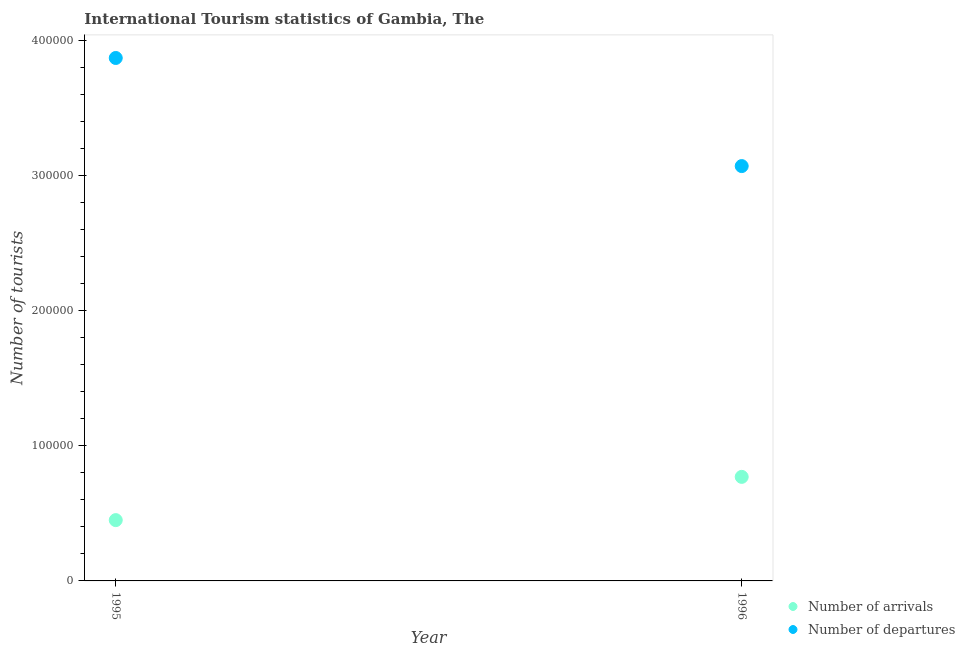How many different coloured dotlines are there?
Your answer should be compact. 2. Is the number of dotlines equal to the number of legend labels?
Offer a very short reply. Yes. What is the number of tourist departures in 1995?
Make the answer very short. 3.87e+05. Across all years, what is the maximum number of tourist departures?
Provide a succinct answer. 3.87e+05. Across all years, what is the minimum number of tourist arrivals?
Provide a short and direct response. 4.50e+04. In which year was the number of tourist departures maximum?
Ensure brevity in your answer.  1995. What is the total number of tourist arrivals in the graph?
Ensure brevity in your answer.  1.22e+05. What is the difference between the number of tourist arrivals in 1995 and that in 1996?
Offer a very short reply. -3.20e+04. What is the difference between the number of tourist departures in 1996 and the number of tourist arrivals in 1995?
Provide a short and direct response. 2.62e+05. What is the average number of tourist arrivals per year?
Provide a succinct answer. 6.10e+04. In the year 1996, what is the difference between the number of tourist arrivals and number of tourist departures?
Give a very brief answer. -2.30e+05. What is the ratio of the number of tourist departures in 1995 to that in 1996?
Make the answer very short. 1.26. Does the number of tourist departures monotonically increase over the years?
Your response must be concise. No. How many dotlines are there?
Keep it short and to the point. 2. How many years are there in the graph?
Offer a terse response. 2. Does the graph contain any zero values?
Your response must be concise. No. Does the graph contain grids?
Your response must be concise. No. Where does the legend appear in the graph?
Make the answer very short. Bottom right. How many legend labels are there?
Your answer should be compact. 2. What is the title of the graph?
Make the answer very short. International Tourism statistics of Gambia, The. Does "Travel services" appear as one of the legend labels in the graph?
Your answer should be compact. No. What is the label or title of the X-axis?
Offer a terse response. Year. What is the label or title of the Y-axis?
Your answer should be very brief. Number of tourists. What is the Number of tourists in Number of arrivals in 1995?
Offer a very short reply. 4.50e+04. What is the Number of tourists of Number of departures in 1995?
Offer a terse response. 3.87e+05. What is the Number of tourists in Number of arrivals in 1996?
Offer a very short reply. 7.70e+04. What is the Number of tourists of Number of departures in 1996?
Your answer should be compact. 3.07e+05. Across all years, what is the maximum Number of tourists of Number of arrivals?
Offer a terse response. 7.70e+04. Across all years, what is the maximum Number of tourists of Number of departures?
Give a very brief answer. 3.87e+05. Across all years, what is the minimum Number of tourists of Number of arrivals?
Ensure brevity in your answer.  4.50e+04. Across all years, what is the minimum Number of tourists of Number of departures?
Give a very brief answer. 3.07e+05. What is the total Number of tourists in Number of arrivals in the graph?
Your response must be concise. 1.22e+05. What is the total Number of tourists in Number of departures in the graph?
Offer a very short reply. 6.94e+05. What is the difference between the Number of tourists in Number of arrivals in 1995 and that in 1996?
Your answer should be compact. -3.20e+04. What is the difference between the Number of tourists in Number of arrivals in 1995 and the Number of tourists in Number of departures in 1996?
Make the answer very short. -2.62e+05. What is the average Number of tourists in Number of arrivals per year?
Ensure brevity in your answer.  6.10e+04. What is the average Number of tourists of Number of departures per year?
Give a very brief answer. 3.47e+05. In the year 1995, what is the difference between the Number of tourists in Number of arrivals and Number of tourists in Number of departures?
Your answer should be compact. -3.42e+05. In the year 1996, what is the difference between the Number of tourists of Number of arrivals and Number of tourists of Number of departures?
Your answer should be very brief. -2.30e+05. What is the ratio of the Number of tourists of Number of arrivals in 1995 to that in 1996?
Provide a succinct answer. 0.58. What is the ratio of the Number of tourists of Number of departures in 1995 to that in 1996?
Give a very brief answer. 1.26. What is the difference between the highest and the second highest Number of tourists of Number of arrivals?
Your response must be concise. 3.20e+04. What is the difference between the highest and the lowest Number of tourists of Number of arrivals?
Keep it short and to the point. 3.20e+04. What is the difference between the highest and the lowest Number of tourists of Number of departures?
Your answer should be compact. 8.00e+04. 